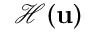<formula> <loc_0><loc_0><loc_500><loc_500>\mathcal { H } ( u )</formula> 